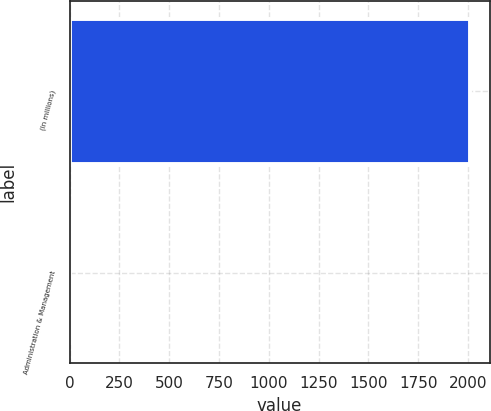Convert chart to OTSL. <chart><loc_0><loc_0><loc_500><loc_500><bar_chart><fcel>(In millions)<fcel>Administration & Management<nl><fcel>2008<fcel>2.7<nl></chart> 